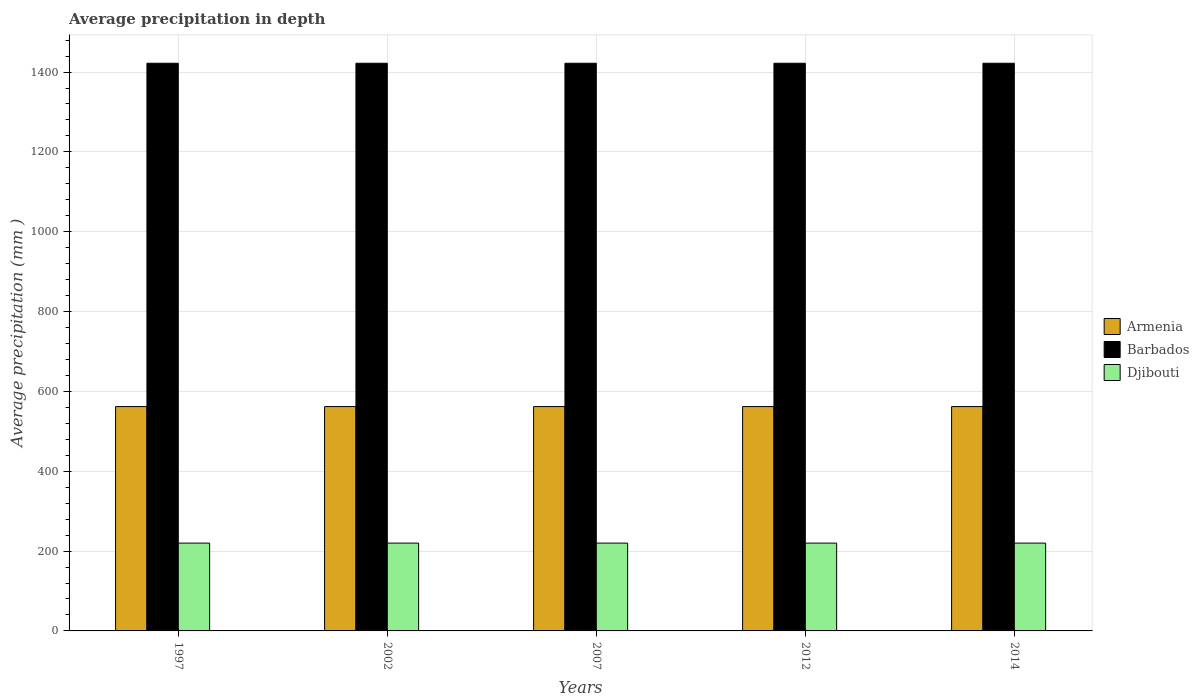How many groups of bars are there?
Your answer should be compact. 5. Are the number of bars on each tick of the X-axis equal?
Your answer should be very brief. Yes. How many bars are there on the 3rd tick from the right?
Your response must be concise. 3. What is the label of the 4th group of bars from the left?
Your answer should be compact. 2012. What is the average precipitation in Armenia in 2014?
Offer a very short reply. 562. Across all years, what is the maximum average precipitation in Djibouti?
Offer a terse response. 220. Across all years, what is the minimum average precipitation in Armenia?
Your answer should be very brief. 562. In which year was the average precipitation in Djibouti minimum?
Your answer should be compact. 1997. What is the total average precipitation in Djibouti in the graph?
Offer a terse response. 1100. What is the difference between the average precipitation in Barbados in 1997 and the average precipitation in Armenia in 2014?
Offer a terse response. 860. What is the average average precipitation in Barbados per year?
Make the answer very short. 1422. In the year 1997, what is the difference between the average precipitation in Armenia and average precipitation in Barbados?
Offer a very short reply. -860. In how many years, is the average precipitation in Djibouti greater than 600 mm?
Offer a very short reply. 0. What is the ratio of the average precipitation in Djibouti in 1997 to that in 2002?
Provide a succinct answer. 1. Is the average precipitation in Armenia in 2012 less than that in 2014?
Offer a very short reply. No. Is the difference between the average precipitation in Armenia in 1997 and 2012 greater than the difference between the average precipitation in Barbados in 1997 and 2012?
Provide a succinct answer. No. What is the difference between the highest and the lowest average precipitation in Armenia?
Give a very brief answer. 0. In how many years, is the average precipitation in Armenia greater than the average average precipitation in Armenia taken over all years?
Your answer should be very brief. 0. Is the sum of the average precipitation in Armenia in 2002 and 2014 greater than the maximum average precipitation in Barbados across all years?
Your answer should be compact. No. What does the 1st bar from the left in 2012 represents?
Give a very brief answer. Armenia. What does the 2nd bar from the right in 1997 represents?
Provide a succinct answer. Barbados. Is it the case that in every year, the sum of the average precipitation in Barbados and average precipitation in Armenia is greater than the average precipitation in Djibouti?
Provide a succinct answer. Yes. How many bars are there?
Ensure brevity in your answer.  15. How many years are there in the graph?
Keep it short and to the point. 5. What is the difference between two consecutive major ticks on the Y-axis?
Offer a terse response. 200. Does the graph contain any zero values?
Provide a succinct answer. No. Does the graph contain grids?
Make the answer very short. Yes. What is the title of the graph?
Your answer should be compact. Average precipitation in depth. What is the label or title of the X-axis?
Ensure brevity in your answer.  Years. What is the label or title of the Y-axis?
Make the answer very short. Average precipitation (mm ). What is the Average precipitation (mm ) in Armenia in 1997?
Your answer should be very brief. 562. What is the Average precipitation (mm ) of Barbados in 1997?
Offer a very short reply. 1422. What is the Average precipitation (mm ) in Djibouti in 1997?
Your answer should be compact. 220. What is the Average precipitation (mm ) of Armenia in 2002?
Make the answer very short. 562. What is the Average precipitation (mm ) in Barbados in 2002?
Ensure brevity in your answer.  1422. What is the Average precipitation (mm ) of Djibouti in 2002?
Your answer should be very brief. 220. What is the Average precipitation (mm ) in Armenia in 2007?
Your answer should be very brief. 562. What is the Average precipitation (mm ) in Barbados in 2007?
Your answer should be compact. 1422. What is the Average precipitation (mm ) in Djibouti in 2007?
Your answer should be compact. 220. What is the Average precipitation (mm ) in Armenia in 2012?
Offer a terse response. 562. What is the Average precipitation (mm ) in Barbados in 2012?
Make the answer very short. 1422. What is the Average precipitation (mm ) in Djibouti in 2012?
Your response must be concise. 220. What is the Average precipitation (mm ) in Armenia in 2014?
Your answer should be very brief. 562. What is the Average precipitation (mm ) of Barbados in 2014?
Provide a succinct answer. 1422. What is the Average precipitation (mm ) in Djibouti in 2014?
Give a very brief answer. 220. Across all years, what is the maximum Average precipitation (mm ) in Armenia?
Keep it short and to the point. 562. Across all years, what is the maximum Average precipitation (mm ) of Barbados?
Your answer should be compact. 1422. Across all years, what is the maximum Average precipitation (mm ) in Djibouti?
Make the answer very short. 220. Across all years, what is the minimum Average precipitation (mm ) of Armenia?
Provide a succinct answer. 562. Across all years, what is the minimum Average precipitation (mm ) of Barbados?
Your response must be concise. 1422. Across all years, what is the minimum Average precipitation (mm ) of Djibouti?
Give a very brief answer. 220. What is the total Average precipitation (mm ) of Armenia in the graph?
Keep it short and to the point. 2810. What is the total Average precipitation (mm ) of Barbados in the graph?
Your answer should be very brief. 7110. What is the total Average precipitation (mm ) of Djibouti in the graph?
Give a very brief answer. 1100. What is the difference between the Average precipitation (mm ) of Armenia in 1997 and that in 2002?
Give a very brief answer. 0. What is the difference between the Average precipitation (mm ) of Barbados in 1997 and that in 2002?
Offer a terse response. 0. What is the difference between the Average precipitation (mm ) of Barbados in 1997 and that in 2007?
Offer a terse response. 0. What is the difference between the Average precipitation (mm ) of Barbados in 1997 and that in 2012?
Your answer should be compact. 0. What is the difference between the Average precipitation (mm ) in Armenia in 1997 and that in 2014?
Offer a terse response. 0. What is the difference between the Average precipitation (mm ) in Djibouti in 1997 and that in 2014?
Your answer should be very brief. 0. What is the difference between the Average precipitation (mm ) in Armenia in 2002 and that in 2007?
Offer a terse response. 0. What is the difference between the Average precipitation (mm ) in Djibouti in 2002 and that in 2007?
Your answer should be very brief. 0. What is the difference between the Average precipitation (mm ) of Djibouti in 2002 and that in 2014?
Provide a succinct answer. 0. What is the difference between the Average precipitation (mm ) of Armenia in 2007 and that in 2012?
Give a very brief answer. 0. What is the difference between the Average precipitation (mm ) of Barbados in 2007 and that in 2012?
Provide a short and direct response. 0. What is the difference between the Average precipitation (mm ) of Djibouti in 2007 and that in 2012?
Your answer should be very brief. 0. What is the difference between the Average precipitation (mm ) in Barbados in 2007 and that in 2014?
Offer a terse response. 0. What is the difference between the Average precipitation (mm ) of Barbados in 2012 and that in 2014?
Offer a very short reply. 0. What is the difference between the Average precipitation (mm ) in Armenia in 1997 and the Average precipitation (mm ) in Barbados in 2002?
Your answer should be very brief. -860. What is the difference between the Average precipitation (mm ) of Armenia in 1997 and the Average precipitation (mm ) of Djibouti in 2002?
Give a very brief answer. 342. What is the difference between the Average precipitation (mm ) in Barbados in 1997 and the Average precipitation (mm ) in Djibouti in 2002?
Provide a succinct answer. 1202. What is the difference between the Average precipitation (mm ) in Armenia in 1997 and the Average precipitation (mm ) in Barbados in 2007?
Ensure brevity in your answer.  -860. What is the difference between the Average precipitation (mm ) in Armenia in 1997 and the Average precipitation (mm ) in Djibouti in 2007?
Your answer should be compact. 342. What is the difference between the Average precipitation (mm ) of Barbados in 1997 and the Average precipitation (mm ) of Djibouti in 2007?
Keep it short and to the point. 1202. What is the difference between the Average precipitation (mm ) in Armenia in 1997 and the Average precipitation (mm ) in Barbados in 2012?
Ensure brevity in your answer.  -860. What is the difference between the Average precipitation (mm ) of Armenia in 1997 and the Average precipitation (mm ) of Djibouti in 2012?
Provide a short and direct response. 342. What is the difference between the Average precipitation (mm ) in Barbados in 1997 and the Average precipitation (mm ) in Djibouti in 2012?
Offer a very short reply. 1202. What is the difference between the Average precipitation (mm ) in Armenia in 1997 and the Average precipitation (mm ) in Barbados in 2014?
Give a very brief answer. -860. What is the difference between the Average precipitation (mm ) of Armenia in 1997 and the Average precipitation (mm ) of Djibouti in 2014?
Offer a very short reply. 342. What is the difference between the Average precipitation (mm ) of Barbados in 1997 and the Average precipitation (mm ) of Djibouti in 2014?
Your response must be concise. 1202. What is the difference between the Average precipitation (mm ) of Armenia in 2002 and the Average precipitation (mm ) of Barbados in 2007?
Provide a succinct answer. -860. What is the difference between the Average precipitation (mm ) in Armenia in 2002 and the Average precipitation (mm ) in Djibouti in 2007?
Ensure brevity in your answer.  342. What is the difference between the Average precipitation (mm ) of Barbados in 2002 and the Average precipitation (mm ) of Djibouti in 2007?
Offer a very short reply. 1202. What is the difference between the Average precipitation (mm ) of Armenia in 2002 and the Average precipitation (mm ) of Barbados in 2012?
Ensure brevity in your answer.  -860. What is the difference between the Average precipitation (mm ) of Armenia in 2002 and the Average precipitation (mm ) of Djibouti in 2012?
Your answer should be very brief. 342. What is the difference between the Average precipitation (mm ) in Barbados in 2002 and the Average precipitation (mm ) in Djibouti in 2012?
Your response must be concise. 1202. What is the difference between the Average precipitation (mm ) of Armenia in 2002 and the Average precipitation (mm ) of Barbados in 2014?
Offer a very short reply. -860. What is the difference between the Average precipitation (mm ) of Armenia in 2002 and the Average precipitation (mm ) of Djibouti in 2014?
Provide a short and direct response. 342. What is the difference between the Average precipitation (mm ) of Barbados in 2002 and the Average precipitation (mm ) of Djibouti in 2014?
Your answer should be very brief. 1202. What is the difference between the Average precipitation (mm ) of Armenia in 2007 and the Average precipitation (mm ) of Barbados in 2012?
Provide a short and direct response. -860. What is the difference between the Average precipitation (mm ) in Armenia in 2007 and the Average precipitation (mm ) in Djibouti in 2012?
Your answer should be compact. 342. What is the difference between the Average precipitation (mm ) in Barbados in 2007 and the Average precipitation (mm ) in Djibouti in 2012?
Your answer should be very brief. 1202. What is the difference between the Average precipitation (mm ) in Armenia in 2007 and the Average precipitation (mm ) in Barbados in 2014?
Offer a terse response. -860. What is the difference between the Average precipitation (mm ) in Armenia in 2007 and the Average precipitation (mm ) in Djibouti in 2014?
Provide a succinct answer. 342. What is the difference between the Average precipitation (mm ) in Barbados in 2007 and the Average precipitation (mm ) in Djibouti in 2014?
Your response must be concise. 1202. What is the difference between the Average precipitation (mm ) in Armenia in 2012 and the Average precipitation (mm ) in Barbados in 2014?
Keep it short and to the point. -860. What is the difference between the Average precipitation (mm ) of Armenia in 2012 and the Average precipitation (mm ) of Djibouti in 2014?
Offer a very short reply. 342. What is the difference between the Average precipitation (mm ) in Barbados in 2012 and the Average precipitation (mm ) in Djibouti in 2014?
Ensure brevity in your answer.  1202. What is the average Average precipitation (mm ) of Armenia per year?
Your answer should be compact. 562. What is the average Average precipitation (mm ) in Barbados per year?
Give a very brief answer. 1422. What is the average Average precipitation (mm ) in Djibouti per year?
Provide a short and direct response. 220. In the year 1997, what is the difference between the Average precipitation (mm ) of Armenia and Average precipitation (mm ) of Barbados?
Keep it short and to the point. -860. In the year 1997, what is the difference between the Average precipitation (mm ) of Armenia and Average precipitation (mm ) of Djibouti?
Keep it short and to the point. 342. In the year 1997, what is the difference between the Average precipitation (mm ) of Barbados and Average precipitation (mm ) of Djibouti?
Ensure brevity in your answer.  1202. In the year 2002, what is the difference between the Average precipitation (mm ) of Armenia and Average precipitation (mm ) of Barbados?
Offer a very short reply. -860. In the year 2002, what is the difference between the Average precipitation (mm ) in Armenia and Average precipitation (mm ) in Djibouti?
Keep it short and to the point. 342. In the year 2002, what is the difference between the Average precipitation (mm ) of Barbados and Average precipitation (mm ) of Djibouti?
Offer a very short reply. 1202. In the year 2007, what is the difference between the Average precipitation (mm ) in Armenia and Average precipitation (mm ) in Barbados?
Make the answer very short. -860. In the year 2007, what is the difference between the Average precipitation (mm ) of Armenia and Average precipitation (mm ) of Djibouti?
Ensure brevity in your answer.  342. In the year 2007, what is the difference between the Average precipitation (mm ) of Barbados and Average precipitation (mm ) of Djibouti?
Your response must be concise. 1202. In the year 2012, what is the difference between the Average precipitation (mm ) of Armenia and Average precipitation (mm ) of Barbados?
Offer a very short reply. -860. In the year 2012, what is the difference between the Average precipitation (mm ) of Armenia and Average precipitation (mm ) of Djibouti?
Provide a short and direct response. 342. In the year 2012, what is the difference between the Average precipitation (mm ) in Barbados and Average precipitation (mm ) in Djibouti?
Provide a short and direct response. 1202. In the year 2014, what is the difference between the Average precipitation (mm ) in Armenia and Average precipitation (mm ) in Barbados?
Provide a succinct answer. -860. In the year 2014, what is the difference between the Average precipitation (mm ) in Armenia and Average precipitation (mm ) in Djibouti?
Your response must be concise. 342. In the year 2014, what is the difference between the Average precipitation (mm ) of Barbados and Average precipitation (mm ) of Djibouti?
Ensure brevity in your answer.  1202. What is the ratio of the Average precipitation (mm ) in Djibouti in 1997 to that in 2002?
Your answer should be compact. 1. What is the ratio of the Average precipitation (mm ) in Djibouti in 1997 to that in 2014?
Offer a terse response. 1. What is the ratio of the Average precipitation (mm ) in Armenia in 2002 to that in 2012?
Your response must be concise. 1. What is the ratio of the Average precipitation (mm ) of Djibouti in 2002 to that in 2012?
Keep it short and to the point. 1. What is the ratio of the Average precipitation (mm ) of Armenia in 2002 to that in 2014?
Make the answer very short. 1. What is the ratio of the Average precipitation (mm ) of Barbados in 2002 to that in 2014?
Offer a terse response. 1. What is the ratio of the Average precipitation (mm ) of Djibouti in 2002 to that in 2014?
Provide a short and direct response. 1. What is the ratio of the Average precipitation (mm ) of Armenia in 2007 to that in 2012?
Offer a very short reply. 1. What is the ratio of the Average precipitation (mm ) of Armenia in 2012 to that in 2014?
Your answer should be very brief. 1. What is the ratio of the Average precipitation (mm ) in Barbados in 2012 to that in 2014?
Keep it short and to the point. 1. What is the difference between the highest and the second highest Average precipitation (mm ) in Armenia?
Provide a succinct answer. 0. What is the difference between the highest and the lowest Average precipitation (mm ) in Barbados?
Ensure brevity in your answer.  0. 